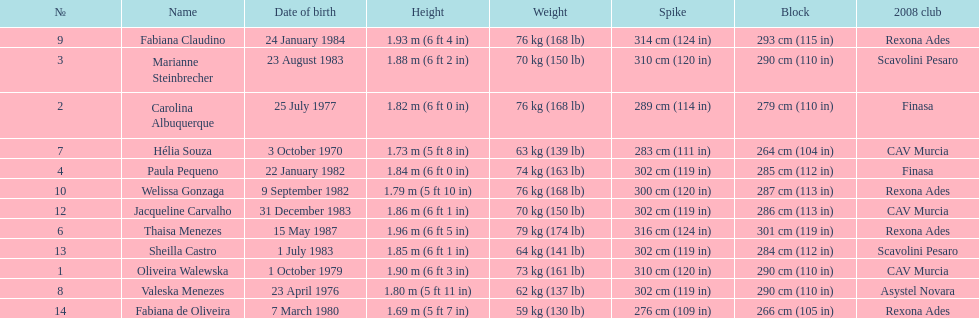Give me the full table as a dictionary. {'header': ['№', 'Name', 'Date of birth', 'Height', 'Weight', 'Spike', 'Block', '2008 club'], 'rows': [['9', 'Fabiana Claudino', '24 January 1984', '1.93\xa0m (6\xa0ft 4\xa0in)', '76\xa0kg (168\xa0lb)', '314\xa0cm (124\xa0in)', '293\xa0cm (115\xa0in)', 'Rexona Ades'], ['3', 'Marianne Steinbrecher', '23 August 1983', '1.88\xa0m (6\xa0ft 2\xa0in)', '70\xa0kg (150\xa0lb)', '310\xa0cm (120\xa0in)', '290\xa0cm (110\xa0in)', 'Scavolini Pesaro'], ['2', 'Carolina Albuquerque', '25 July 1977', '1.82\xa0m (6\xa0ft 0\xa0in)', '76\xa0kg (168\xa0lb)', '289\xa0cm (114\xa0in)', '279\xa0cm (110\xa0in)', 'Finasa'], ['7', 'Hélia Souza', '3 October 1970', '1.73\xa0m (5\xa0ft 8\xa0in)', '63\xa0kg (139\xa0lb)', '283\xa0cm (111\xa0in)', '264\xa0cm (104\xa0in)', 'CAV Murcia'], ['4', 'Paula Pequeno', '22 January 1982', '1.84\xa0m (6\xa0ft 0\xa0in)', '74\xa0kg (163\xa0lb)', '302\xa0cm (119\xa0in)', '285\xa0cm (112\xa0in)', 'Finasa'], ['10', 'Welissa Gonzaga', '9 September 1982', '1.79\xa0m (5\xa0ft 10\xa0in)', '76\xa0kg (168\xa0lb)', '300\xa0cm (120\xa0in)', '287\xa0cm (113\xa0in)', 'Rexona Ades'], ['12', 'Jacqueline Carvalho', '31 December 1983', '1.86\xa0m (6\xa0ft 1\xa0in)', '70\xa0kg (150\xa0lb)', '302\xa0cm (119\xa0in)', '286\xa0cm (113\xa0in)', 'CAV Murcia'], ['6', 'Thaisa Menezes', '15 May 1987', '1.96\xa0m (6\xa0ft 5\xa0in)', '79\xa0kg (174\xa0lb)', '316\xa0cm (124\xa0in)', '301\xa0cm (119\xa0in)', 'Rexona Ades'], ['13', 'Sheilla Castro', '1 July 1983', '1.85\xa0m (6\xa0ft 1\xa0in)', '64\xa0kg (141\xa0lb)', '302\xa0cm (119\xa0in)', '284\xa0cm (112\xa0in)', 'Scavolini Pesaro'], ['1', 'Oliveira Walewska', '1 October 1979', '1.90\xa0m (6\xa0ft 3\xa0in)', '73\xa0kg (161\xa0lb)', '310\xa0cm (120\xa0in)', '290\xa0cm (110\xa0in)', 'CAV Murcia'], ['8', 'Valeska Menezes', '23 April 1976', '1.80\xa0m (5\xa0ft 11\xa0in)', '62\xa0kg (137\xa0lb)', '302\xa0cm (119\xa0in)', '290\xa0cm (110\xa0in)', 'Asystel Novara'], ['14', 'Fabiana de Oliveira', '7 March 1980', '1.69\xa0m (5\xa0ft 7\xa0in)', '59\xa0kg (130\xa0lb)', '276\xa0cm (109\xa0in)', '266\xa0cm (105\xa0in)', 'Rexona Ades']]} Among fabiana de oliveira, helia souza, and sheilla castro, who possesses the heaviest weight? Sheilla Castro. 